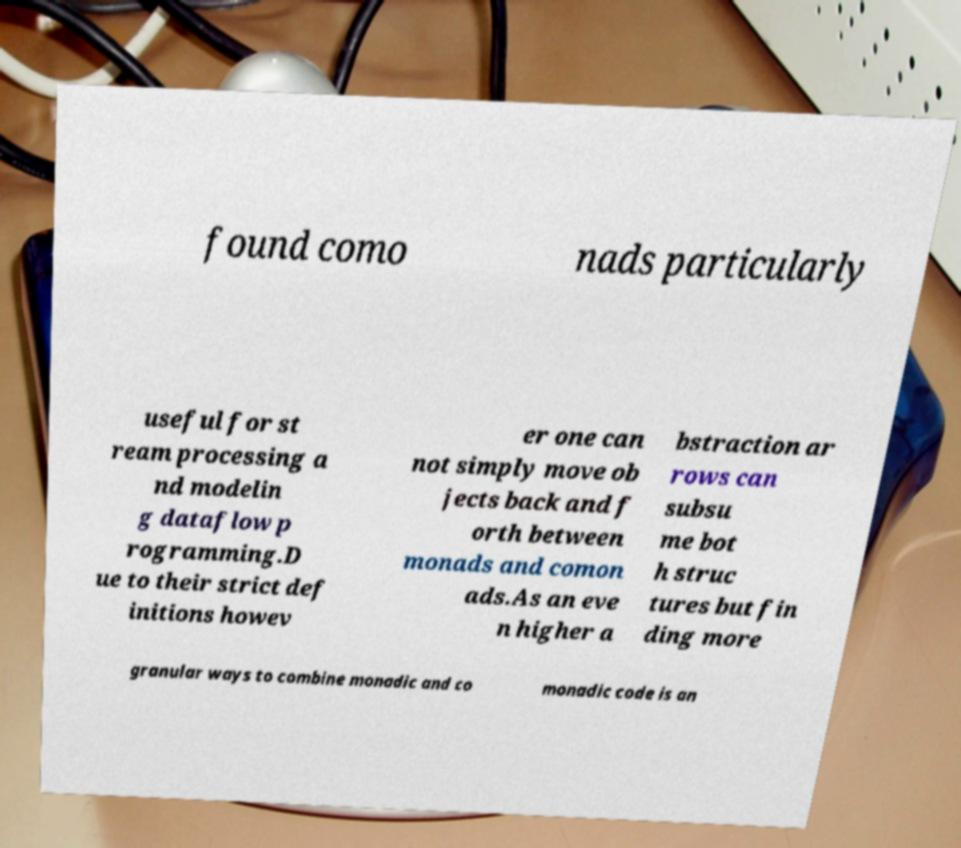For documentation purposes, I need the text within this image transcribed. Could you provide that? found como nads particularly useful for st ream processing a nd modelin g dataflow p rogramming.D ue to their strict def initions howev er one can not simply move ob jects back and f orth between monads and comon ads.As an eve n higher a bstraction ar rows can subsu me bot h struc tures but fin ding more granular ways to combine monadic and co monadic code is an 